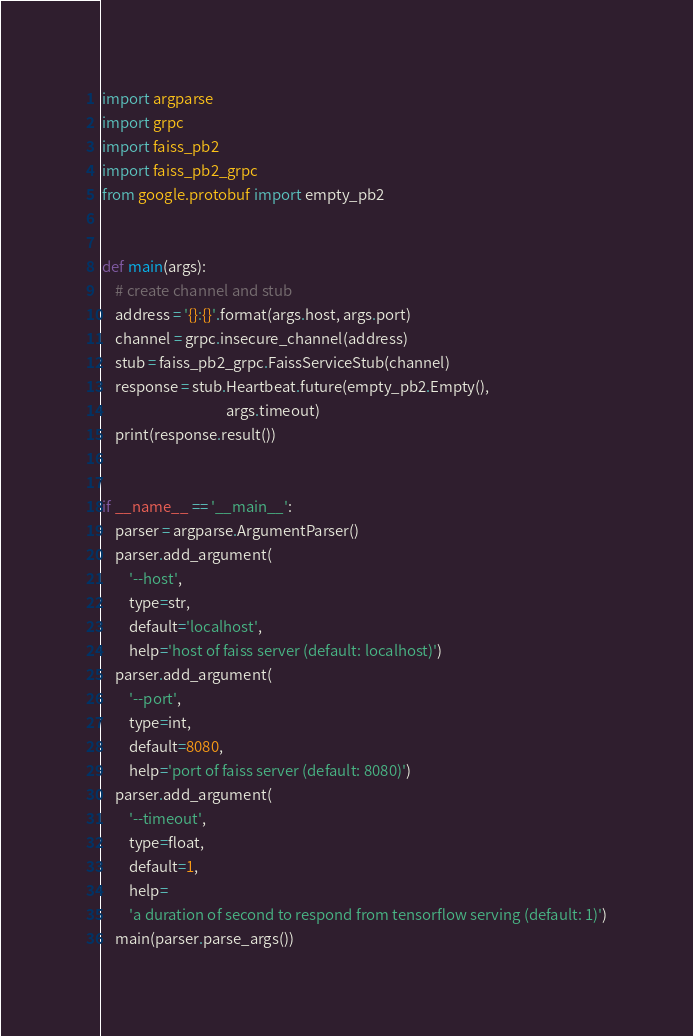<code> <loc_0><loc_0><loc_500><loc_500><_Python_>import argparse
import grpc
import faiss_pb2
import faiss_pb2_grpc
from google.protobuf import empty_pb2


def main(args):
    # create channel and stub
    address = '{}:{}'.format(args.host, args.port)
    channel = grpc.insecure_channel(address)
    stub = faiss_pb2_grpc.FaissServiceStub(channel)
    response = stub.Heartbeat.future(empty_pb2.Empty(),
                                     args.timeout)
    print(response.result())


if __name__ == '__main__':
    parser = argparse.ArgumentParser()
    parser.add_argument(
        '--host',
        type=str,
        default='localhost',
        help='host of faiss server (default: localhost)')
    parser.add_argument(
        '--port',
        type=int,
        default=8080,
        help='port of faiss server (default: 8080)')
    parser.add_argument(
        '--timeout',
        type=float,
        default=1,
        help=
        'a duration of second to respond from tensorflow serving (default: 1)')
    main(parser.parse_args())
</code> 